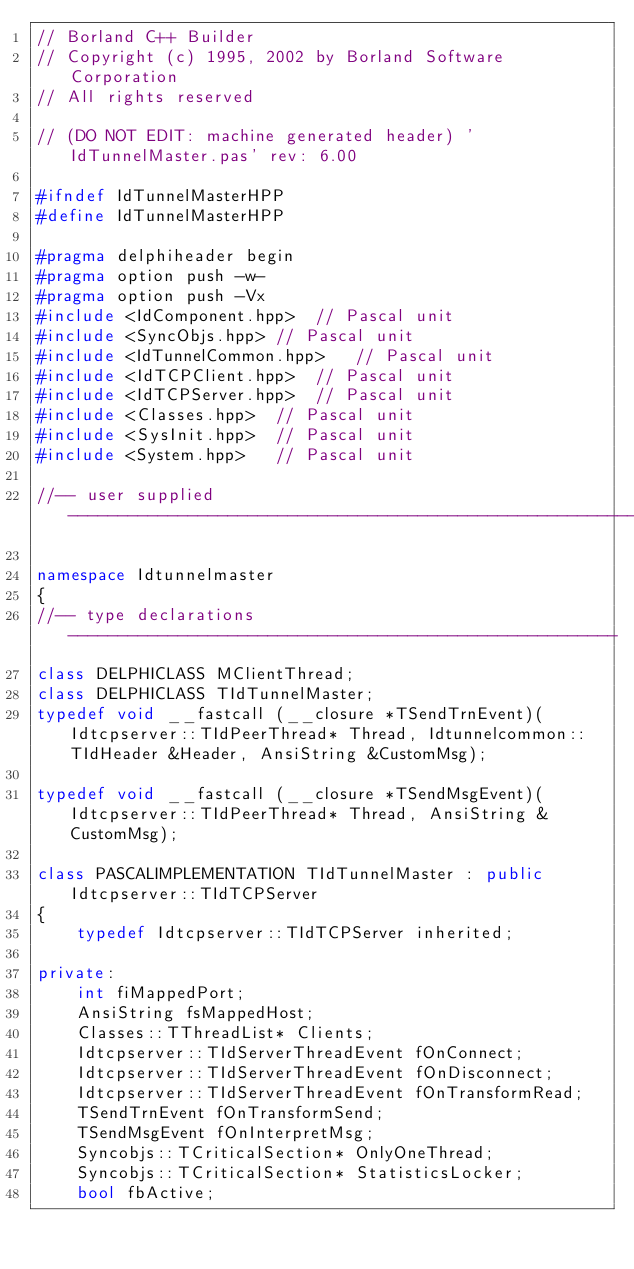Convert code to text. <code><loc_0><loc_0><loc_500><loc_500><_C++_>// Borland C++ Builder
// Copyright (c) 1995, 2002 by Borland Software Corporation
// All rights reserved

// (DO NOT EDIT: machine generated header) 'IdTunnelMaster.pas' rev: 6.00

#ifndef IdTunnelMasterHPP
#define IdTunnelMasterHPP

#pragma delphiheader begin
#pragma option push -w-
#pragma option push -Vx
#include <IdComponent.hpp>	// Pascal unit
#include <SyncObjs.hpp>	// Pascal unit
#include <IdTunnelCommon.hpp>	// Pascal unit
#include <IdTCPClient.hpp>	// Pascal unit
#include <IdTCPServer.hpp>	// Pascal unit
#include <Classes.hpp>	// Pascal unit
#include <SysInit.hpp>	// Pascal unit
#include <System.hpp>	// Pascal unit

//-- user supplied -----------------------------------------------------------

namespace Idtunnelmaster
{
//-- type declarations -------------------------------------------------------
class DELPHICLASS MClientThread;
class DELPHICLASS TIdTunnelMaster;
typedef void __fastcall (__closure *TSendTrnEvent)(Idtcpserver::TIdPeerThread* Thread, Idtunnelcommon::TIdHeader &Header, AnsiString &CustomMsg);

typedef void __fastcall (__closure *TSendMsgEvent)(Idtcpserver::TIdPeerThread* Thread, AnsiString &CustomMsg);

class PASCALIMPLEMENTATION TIdTunnelMaster : public Idtcpserver::TIdTCPServer 
{
	typedef Idtcpserver::TIdTCPServer inherited;
	
private:
	int fiMappedPort;
	AnsiString fsMappedHost;
	Classes::TThreadList* Clients;
	Idtcpserver::TIdServerThreadEvent fOnConnect;
	Idtcpserver::TIdServerThreadEvent fOnDisconnect;
	Idtcpserver::TIdServerThreadEvent fOnTransformRead;
	TSendTrnEvent fOnTransformSend;
	TSendMsgEvent fOnInterpretMsg;
	Syncobjs::TCriticalSection* OnlyOneThread;
	Syncobjs::TCriticalSection* StatisticsLocker;
	bool fbActive;</code> 